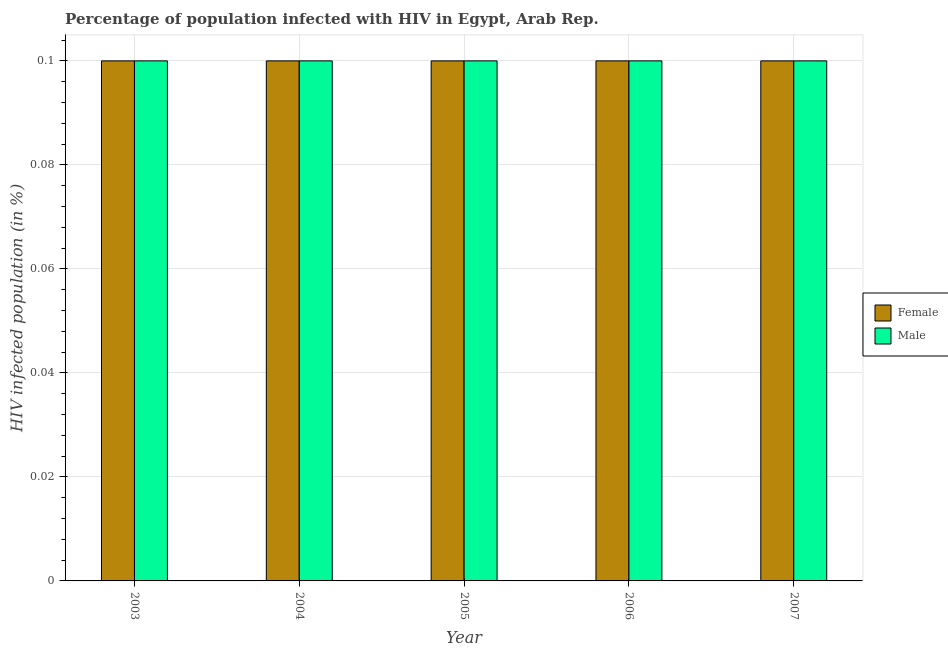Are the number of bars per tick equal to the number of legend labels?
Provide a succinct answer. Yes. Are the number of bars on each tick of the X-axis equal?
Offer a very short reply. Yes. How many bars are there on the 1st tick from the left?
Your answer should be very brief. 2. What is the label of the 5th group of bars from the left?
Your answer should be very brief. 2007. What is the percentage of males who are infected with hiv in 2004?
Your response must be concise. 0.1. Across all years, what is the maximum percentage of females who are infected with hiv?
Your response must be concise. 0.1. What is the total percentage of females who are infected with hiv in the graph?
Provide a short and direct response. 0.5. What is the difference between the percentage of females who are infected with hiv in 2005 and the percentage of males who are infected with hiv in 2006?
Provide a short and direct response. 0. What is the average percentage of females who are infected with hiv per year?
Provide a succinct answer. 0.1. In how many years, is the percentage of males who are infected with hiv greater than 0.06 %?
Give a very brief answer. 5. What is the ratio of the percentage of males who are infected with hiv in 2005 to that in 2006?
Your answer should be very brief. 1. What is the difference between the highest and the lowest percentage of males who are infected with hiv?
Your response must be concise. 0. In how many years, is the percentage of females who are infected with hiv greater than the average percentage of females who are infected with hiv taken over all years?
Your answer should be very brief. 0. What does the 1st bar from the right in 2007 represents?
Offer a very short reply. Male. How many bars are there?
Keep it short and to the point. 10. Are all the bars in the graph horizontal?
Offer a very short reply. No. How many years are there in the graph?
Your answer should be compact. 5. What is the difference between two consecutive major ticks on the Y-axis?
Provide a short and direct response. 0.02. Are the values on the major ticks of Y-axis written in scientific E-notation?
Offer a terse response. No. Does the graph contain any zero values?
Offer a very short reply. No. How many legend labels are there?
Offer a very short reply. 2. What is the title of the graph?
Provide a succinct answer. Percentage of population infected with HIV in Egypt, Arab Rep. Does "Savings" appear as one of the legend labels in the graph?
Provide a short and direct response. No. What is the label or title of the X-axis?
Offer a very short reply. Year. What is the label or title of the Y-axis?
Offer a terse response. HIV infected population (in %). What is the HIV infected population (in %) in Male in 2003?
Ensure brevity in your answer.  0.1. What is the HIV infected population (in %) of Male in 2005?
Offer a very short reply. 0.1. What is the HIV infected population (in %) in Female in 2006?
Keep it short and to the point. 0.1. What is the HIV infected population (in %) in Male in 2006?
Keep it short and to the point. 0.1. What is the HIV infected population (in %) in Female in 2007?
Provide a succinct answer. 0.1. Across all years, what is the maximum HIV infected population (in %) of Male?
Give a very brief answer. 0.1. Across all years, what is the minimum HIV infected population (in %) of Female?
Provide a succinct answer. 0.1. What is the total HIV infected population (in %) of Female in the graph?
Keep it short and to the point. 0.5. What is the total HIV infected population (in %) in Male in the graph?
Offer a very short reply. 0.5. What is the difference between the HIV infected population (in %) in Female in 2003 and that in 2004?
Keep it short and to the point. 0. What is the difference between the HIV infected population (in %) in Male in 2003 and that in 2005?
Offer a terse response. 0. What is the difference between the HIV infected population (in %) of Female in 2003 and that in 2006?
Give a very brief answer. 0. What is the difference between the HIV infected population (in %) of Male in 2003 and that in 2006?
Keep it short and to the point. 0. What is the difference between the HIV infected population (in %) in Female in 2004 and that in 2007?
Your answer should be compact. 0. What is the difference between the HIV infected population (in %) of Female in 2005 and that in 2006?
Your response must be concise. 0. What is the difference between the HIV infected population (in %) in Male in 2005 and that in 2007?
Offer a very short reply. 0. What is the difference between the HIV infected population (in %) in Female in 2003 and the HIV infected population (in %) in Male in 2006?
Your answer should be very brief. 0. What is the difference between the HIV infected population (in %) of Female in 2003 and the HIV infected population (in %) of Male in 2007?
Your response must be concise. 0. What is the difference between the HIV infected population (in %) in Female in 2004 and the HIV infected population (in %) in Male in 2007?
Ensure brevity in your answer.  0. What is the difference between the HIV infected population (in %) of Female in 2005 and the HIV infected population (in %) of Male in 2006?
Keep it short and to the point. 0. What is the difference between the HIV infected population (in %) in Female in 2005 and the HIV infected population (in %) in Male in 2007?
Give a very brief answer. 0. What is the average HIV infected population (in %) in Male per year?
Ensure brevity in your answer.  0.1. In the year 2004, what is the difference between the HIV infected population (in %) in Female and HIV infected population (in %) in Male?
Make the answer very short. 0. What is the ratio of the HIV infected population (in %) in Male in 2003 to that in 2004?
Offer a very short reply. 1. What is the ratio of the HIV infected population (in %) of Female in 2004 to that in 2005?
Provide a short and direct response. 1. What is the ratio of the HIV infected population (in %) of Male in 2004 to that in 2005?
Your answer should be compact. 1. What is the ratio of the HIV infected population (in %) in Male in 2004 to that in 2007?
Make the answer very short. 1. What is the ratio of the HIV infected population (in %) of Male in 2005 to that in 2006?
Your response must be concise. 1. What is the ratio of the HIV infected population (in %) in Female in 2005 to that in 2007?
Keep it short and to the point. 1. What is the ratio of the HIV infected population (in %) of Male in 2005 to that in 2007?
Your answer should be compact. 1. What is the ratio of the HIV infected population (in %) of Female in 2006 to that in 2007?
Your answer should be very brief. 1. What is the ratio of the HIV infected population (in %) of Male in 2006 to that in 2007?
Offer a terse response. 1. What is the difference between the highest and the lowest HIV infected population (in %) in Male?
Your answer should be very brief. 0. 